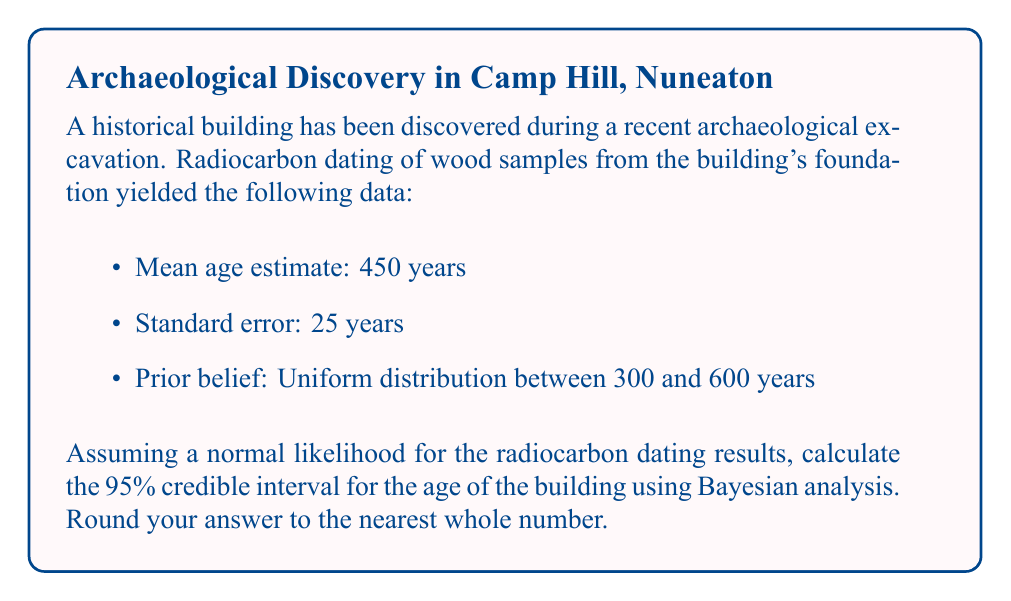Help me with this question. To calculate the credible interval using Bayesian analysis, we'll follow these steps:

1) First, let's define our variables:
   $\mu$ = 450 (mean age estimate)
   $\sigma$ = 25 (standard error)
   
2) The likelihood function is normal: $p(x|\theta) \sim N(\mu, \sigma^2)$

3) The prior is uniform between 300 and 600 years:
   $p(\theta) = \frac{1}{600-300} = \frac{1}{300}$ for $300 \leq \theta \leq 600$

4) For a normal likelihood and uniform prior, the posterior distribution is also normal with parameters:

   $\mu_{posterior} = \mu = 450$
   $\sigma_{posterior} = \sigma = 25$

5) For a 95% credible interval of a normal distribution, we use the formula:
   $[\mu - 1.96\sigma, \mu + 1.96\sigma]$

6) Plugging in our values:
   $[450 - 1.96(25), 450 + 1.96(25)]$
   $[450 - 49, 450 + 49]$
   $[401, 499]$

7) Rounding to the nearest whole number:
   $[401, 499]$

Therefore, we can be 95% confident that the true age of the building falls between 401 and 499 years.
Answer: [401, 499] years 